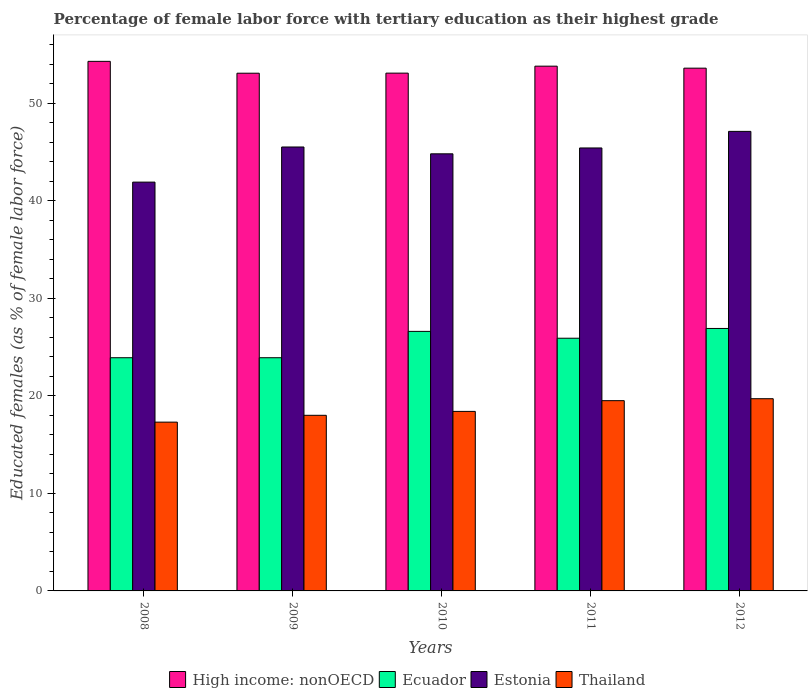How many groups of bars are there?
Your answer should be compact. 5. Are the number of bars per tick equal to the number of legend labels?
Ensure brevity in your answer.  Yes. How many bars are there on the 1st tick from the left?
Provide a succinct answer. 4. How many bars are there on the 3rd tick from the right?
Offer a very short reply. 4. What is the percentage of female labor force with tertiary education in Ecuador in 2009?
Ensure brevity in your answer.  23.9. Across all years, what is the maximum percentage of female labor force with tertiary education in Estonia?
Your response must be concise. 47.1. Across all years, what is the minimum percentage of female labor force with tertiary education in Ecuador?
Keep it short and to the point. 23.9. What is the total percentage of female labor force with tertiary education in Estonia in the graph?
Offer a terse response. 224.7. What is the difference between the percentage of female labor force with tertiary education in Thailand in 2011 and that in 2012?
Ensure brevity in your answer.  -0.2. What is the difference between the percentage of female labor force with tertiary education in Estonia in 2010 and the percentage of female labor force with tertiary education in Thailand in 2009?
Offer a very short reply. 26.8. What is the average percentage of female labor force with tertiary education in Ecuador per year?
Offer a very short reply. 25.44. In the year 2011, what is the difference between the percentage of female labor force with tertiary education in Thailand and percentage of female labor force with tertiary education in Estonia?
Your response must be concise. -25.9. In how many years, is the percentage of female labor force with tertiary education in Ecuador greater than 46 %?
Your response must be concise. 0. What is the ratio of the percentage of female labor force with tertiary education in Estonia in 2008 to that in 2012?
Give a very brief answer. 0.89. What is the difference between the highest and the second highest percentage of female labor force with tertiary education in Estonia?
Ensure brevity in your answer.  1.6. What is the difference between the highest and the lowest percentage of female labor force with tertiary education in Estonia?
Make the answer very short. 5.2. In how many years, is the percentage of female labor force with tertiary education in High income: nonOECD greater than the average percentage of female labor force with tertiary education in High income: nonOECD taken over all years?
Make the answer very short. 3. Is the sum of the percentage of female labor force with tertiary education in Estonia in 2008 and 2011 greater than the maximum percentage of female labor force with tertiary education in Ecuador across all years?
Your answer should be compact. Yes. What does the 3rd bar from the left in 2010 represents?
Provide a short and direct response. Estonia. What does the 3rd bar from the right in 2011 represents?
Your response must be concise. Ecuador. Is it the case that in every year, the sum of the percentage of female labor force with tertiary education in Ecuador and percentage of female labor force with tertiary education in Thailand is greater than the percentage of female labor force with tertiary education in Estonia?
Offer a terse response. No. How many bars are there?
Your response must be concise. 20. How many years are there in the graph?
Provide a short and direct response. 5. Does the graph contain any zero values?
Provide a short and direct response. No. Does the graph contain grids?
Keep it short and to the point. No. Where does the legend appear in the graph?
Offer a very short reply. Bottom center. How many legend labels are there?
Provide a succinct answer. 4. How are the legend labels stacked?
Provide a succinct answer. Horizontal. What is the title of the graph?
Your answer should be compact. Percentage of female labor force with tertiary education as their highest grade. Does "Morocco" appear as one of the legend labels in the graph?
Your answer should be compact. No. What is the label or title of the Y-axis?
Keep it short and to the point. Educated females (as % of female labor force). What is the Educated females (as % of female labor force) of High income: nonOECD in 2008?
Your answer should be very brief. 54.28. What is the Educated females (as % of female labor force) of Ecuador in 2008?
Your answer should be very brief. 23.9. What is the Educated females (as % of female labor force) in Estonia in 2008?
Make the answer very short. 41.9. What is the Educated females (as % of female labor force) in Thailand in 2008?
Provide a short and direct response. 17.3. What is the Educated females (as % of female labor force) in High income: nonOECD in 2009?
Offer a terse response. 53.06. What is the Educated females (as % of female labor force) in Ecuador in 2009?
Your answer should be compact. 23.9. What is the Educated females (as % of female labor force) in Estonia in 2009?
Provide a short and direct response. 45.5. What is the Educated females (as % of female labor force) of High income: nonOECD in 2010?
Provide a succinct answer. 53.07. What is the Educated females (as % of female labor force) of Ecuador in 2010?
Keep it short and to the point. 26.6. What is the Educated females (as % of female labor force) of Estonia in 2010?
Make the answer very short. 44.8. What is the Educated females (as % of female labor force) of Thailand in 2010?
Ensure brevity in your answer.  18.4. What is the Educated females (as % of female labor force) in High income: nonOECD in 2011?
Offer a very short reply. 53.78. What is the Educated females (as % of female labor force) of Ecuador in 2011?
Your answer should be very brief. 25.9. What is the Educated females (as % of female labor force) in Estonia in 2011?
Offer a terse response. 45.4. What is the Educated females (as % of female labor force) of Thailand in 2011?
Ensure brevity in your answer.  19.5. What is the Educated females (as % of female labor force) of High income: nonOECD in 2012?
Offer a very short reply. 53.58. What is the Educated females (as % of female labor force) of Ecuador in 2012?
Provide a short and direct response. 26.9. What is the Educated females (as % of female labor force) in Estonia in 2012?
Offer a terse response. 47.1. What is the Educated females (as % of female labor force) of Thailand in 2012?
Give a very brief answer. 19.7. Across all years, what is the maximum Educated females (as % of female labor force) in High income: nonOECD?
Your response must be concise. 54.28. Across all years, what is the maximum Educated females (as % of female labor force) of Ecuador?
Make the answer very short. 26.9. Across all years, what is the maximum Educated females (as % of female labor force) in Estonia?
Offer a terse response. 47.1. Across all years, what is the maximum Educated females (as % of female labor force) of Thailand?
Give a very brief answer. 19.7. Across all years, what is the minimum Educated females (as % of female labor force) in High income: nonOECD?
Provide a succinct answer. 53.06. Across all years, what is the minimum Educated females (as % of female labor force) in Ecuador?
Make the answer very short. 23.9. Across all years, what is the minimum Educated females (as % of female labor force) in Estonia?
Offer a terse response. 41.9. Across all years, what is the minimum Educated females (as % of female labor force) of Thailand?
Give a very brief answer. 17.3. What is the total Educated females (as % of female labor force) in High income: nonOECD in the graph?
Offer a terse response. 267.77. What is the total Educated females (as % of female labor force) of Ecuador in the graph?
Keep it short and to the point. 127.2. What is the total Educated females (as % of female labor force) of Estonia in the graph?
Your response must be concise. 224.7. What is the total Educated females (as % of female labor force) of Thailand in the graph?
Offer a terse response. 92.9. What is the difference between the Educated females (as % of female labor force) in High income: nonOECD in 2008 and that in 2009?
Your response must be concise. 1.22. What is the difference between the Educated females (as % of female labor force) in Ecuador in 2008 and that in 2009?
Ensure brevity in your answer.  0. What is the difference between the Educated females (as % of female labor force) in High income: nonOECD in 2008 and that in 2010?
Make the answer very short. 1.21. What is the difference between the Educated females (as % of female labor force) in Ecuador in 2008 and that in 2010?
Your answer should be very brief. -2.7. What is the difference between the Educated females (as % of female labor force) in Estonia in 2008 and that in 2010?
Your response must be concise. -2.9. What is the difference between the Educated females (as % of female labor force) in High income: nonOECD in 2008 and that in 2011?
Ensure brevity in your answer.  0.49. What is the difference between the Educated females (as % of female labor force) in Thailand in 2008 and that in 2011?
Provide a succinct answer. -2.2. What is the difference between the Educated females (as % of female labor force) of High income: nonOECD in 2008 and that in 2012?
Ensure brevity in your answer.  0.7. What is the difference between the Educated females (as % of female labor force) in Ecuador in 2008 and that in 2012?
Make the answer very short. -3. What is the difference between the Educated females (as % of female labor force) in Estonia in 2008 and that in 2012?
Make the answer very short. -5.2. What is the difference between the Educated females (as % of female labor force) of Thailand in 2008 and that in 2012?
Make the answer very short. -2.4. What is the difference between the Educated females (as % of female labor force) in High income: nonOECD in 2009 and that in 2010?
Offer a very short reply. -0.01. What is the difference between the Educated females (as % of female labor force) in Ecuador in 2009 and that in 2010?
Your answer should be very brief. -2.7. What is the difference between the Educated females (as % of female labor force) of Estonia in 2009 and that in 2010?
Ensure brevity in your answer.  0.7. What is the difference between the Educated females (as % of female labor force) in High income: nonOECD in 2009 and that in 2011?
Your answer should be very brief. -0.72. What is the difference between the Educated females (as % of female labor force) in Thailand in 2009 and that in 2011?
Provide a succinct answer. -1.5. What is the difference between the Educated females (as % of female labor force) in High income: nonOECD in 2009 and that in 2012?
Give a very brief answer. -0.52. What is the difference between the Educated females (as % of female labor force) in Estonia in 2009 and that in 2012?
Make the answer very short. -1.6. What is the difference between the Educated females (as % of female labor force) of High income: nonOECD in 2010 and that in 2011?
Provide a succinct answer. -0.71. What is the difference between the Educated females (as % of female labor force) of Ecuador in 2010 and that in 2011?
Provide a short and direct response. 0.7. What is the difference between the Educated females (as % of female labor force) of High income: nonOECD in 2010 and that in 2012?
Your answer should be very brief. -0.51. What is the difference between the Educated females (as % of female labor force) of Ecuador in 2010 and that in 2012?
Keep it short and to the point. -0.3. What is the difference between the Educated females (as % of female labor force) in High income: nonOECD in 2011 and that in 2012?
Keep it short and to the point. 0.2. What is the difference between the Educated females (as % of female labor force) of Ecuador in 2011 and that in 2012?
Provide a succinct answer. -1. What is the difference between the Educated females (as % of female labor force) of High income: nonOECD in 2008 and the Educated females (as % of female labor force) of Ecuador in 2009?
Give a very brief answer. 30.38. What is the difference between the Educated females (as % of female labor force) of High income: nonOECD in 2008 and the Educated females (as % of female labor force) of Estonia in 2009?
Your response must be concise. 8.78. What is the difference between the Educated females (as % of female labor force) in High income: nonOECD in 2008 and the Educated females (as % of female labor force) in Thailand in 2009?
Offer a terse response. 36.28. What is the difference between the Educated females (as % of female labor force) in Ecuador in 2008 and the Educated females (as % of female labor force) in Estonia in 2009?
Provide a succinct answer. -21.6. What is the difference between the Educated females (as % of female labor force) of Estonia in 2008 and the Educated females (as % of female labor force) of Thailand in 2009?
Provide a succinct answer. 23.9. What is the difference between the Educated females (as % of female labor force) of High income: nonOECD in 2008 and the Educated females (as % of female labor force) of Ecuador in 2010?
Keep it short and to the point. 27.68. What is the difference between the Educated females (as % of female labor force) of High income: nonOECD in 2008 and the Educated females (as % of female labor force) of Estonia in 2010?
Provide a short and direct response. 9.48. What is the difference between the Educated females (as % of female labor force) of High income: nonOECD in 2008 and the Educated females (as % of female labor force) of Thailand in 2010?
Offer a terse response. 35.88. What is the difference between the Educated females (as % of female labor force) in Ecuador in 2008 and the Educated females (as % of female labor force) in Estonia in 2010?
Make the answer very short. -20.9. What is the difference between the Educated females (as % of female labor force) in High income: nonOECD in 2008 and the Educated females (as % of female labor force) in Ecuador in 2011?
Offer a terse response. 28.38. What is the difference between the Educated females (as % of female labor force) of High income: nonOECD in 2008 and the Educated females (as % of female labor force) of Estonia in 2011?
Make the answer very short. 8.88. What is the difference between the Educated females (as % of female labor force) in High income: nonOECD in 2008 and the Educated females (as % of female labor force) in Thailand in 2011?
Give a very brief answer. 34.78. What is the difference between the Educated females (as % of female labor force) in Ecuador in 2008 and the Educated females (as % of female labor force) in Estonia in 2011?
Ensure brevity in your answer.  -21.5. What is the difference between the Educated females (as % of female labor force) of Ecuador in 2008 and the Educated females (as % of female labor force) of Thailand in 2011?
Offer a terse response. 4.4. What is the difference between the Educated females (as % of female labor force) in Estonia in 2008 and the Educated females (as % of female labor force) in Thailand in 2011?
Provide a short and direct response. 22.4. What is the difference between the Educated females (as % of female labor force) of High income: nonOECD in 2008 and the Educated females (as % of female labor force) of Ecuador in 2012?
Provide a short and direct response. 27.38. What is the difference between the Educated females (as % of female labor force) of High income: nonOECD in 2008 and the Educated females (as % of female labor force) of Estonia in 2012?
Ensure brevity in your answer.  7.18. What is the difference between the Educated females (as % of female labor force) in High income: nonOECD in 2008 and the Educated females (as % of female labor force) in Thailand in 2012?
Provide a short and direct response. 34.58. What is the difference between the Educated females (as % of female labor force) of Ecuador in 2008 and the Educated females (as % of female labor force) of Estonia in 2012?
Your answer should be compact. -23.2. What is the difference between the Educated females (as % of female labor force) of Ecuador in 2008 and the Educated females (as % of female labor force) of Thailand in 2012?
Make the answer very short. 4.2. What is the difference between the Educated females (as % of female labor force) of High income: nonOECD in 2009 and the Educated females (as % of female labor force) of Ecuador in 2010?
Give a very brief answer. 26.46. What is the difference between the Educated females (as % of female labor force) in High income: nonOECD in 2009 and the Educated females (as % of female labor force) in Estonia in 2010?
Offer a terse response. 8.26. What is the difference between the Educated females (as % of female labor force) of High income: nonOECD in 2009 and the Educated females (as % of female labor force) of Thailand in 2010?
Your response must be concise. 34.66. What is the difference between the Educated females (as % of female labor force) in Ecuador in 2009 and the Educated females (as % of female labor force) in Estonia in 2010?
Make the answer very short. -20.9. What is the difference between the Educated females (as % of female labor force) of Ecuador in 2009 and the Educated females (as % of female labor force) of Thailand in 2010?
Ensure brevity in your answer.  5.5. What is the difference between the Educated females (as % of female labor force) in Estonia in 2009 and the Educated females (as % of female labor force) in Thailand in 2010?
Make the answer very short. 27.1. What is the difference between the Educated females (as % of female labor force) in High income: nonOECD in 2009 and the Educated females (as % of female labor force) in Ecuador in 2011?
Offer a terse response. 27.16. What is the difference between the Educated females (as % of female labor force) in High income: nonOECD in 2009 and the Educated females (as % of female labor force) in Estonia in 2011?
Your answer should be compact. 7.66. What is the difference between the Educated females (as % of female labor force) in High income: nonOECD in 2009 and the Educated females (as % of female labor force) in Thailand in 2011?
Keep it short and to the point. 33.56. What is the difference between the Educated females (as % of female labor force) of Ecuador in 2009 and the Educated females (as % of female labor force) of Estonia in 2011?
Provide a succinct answer. -21.5. What is the difference between the Educated females (as % of female labor force) of Ecuador in 2009 and the Educated females (as % of female labor force) of Thailand in 2011?
Your answer should be very brief. 4.4. What is the difference between the Educated females (as % of female labor force) in Estonia in 2009 and the Educated females (as % of female labor force) in Thailand in 2011?
Give a very brief answer. 26. What is the difference between the Educated females (as % of female labor force) in High income: nonOECD in 2009 and the Educated females (as % of female labor force) in Ecuador in 2012?
Your response must be concise. 26.16. What is the difference between the Educated females (as % of female labor force) of High income: nonOECD in 2009 and the Educated females (as % of female labor force) of Estonia in 2012?
Give a very brief answer. 5.96. What is the difference between the Educated females (as % of female labor force) of High income: nonOECD in 2009 and the Educated females (as % of female labor force) of Thailand in 2012?
Provide a short and direct response. 33.36. What is the difference between the Educated females (as % of female labor force) of Ecuador in 2009 and the Educated females (as % of female labor force) of Estonia in 2012?
Ensure brevity in your answer.  -23.2. What is the difference between the Educated females (as % of female labor force) in Estonia in 2009 and the Educated females (as % of female labor force) in Thailand in 2012?
Offer a terse response. 25.8. What is the difference between the Educated females (as % of female labor force) in High income: nonOECD in 2010 and the Educated females (as % of female labor force) in Ecuador in 2011?
Make the answer very short. 27.17. What is the difference between the Educated females (as % of female labor force) in High income: nonOECD in 2010 and the Educated females (as % of female labor force) in Estonia in 2011?
Offer a terse response. 7.67. What is the difference between the Educated females (as % of female labor force) in High income: nonOECD in 2010 and the Educated females (as % of female labor force) in Thailand in 2011?
Offer a terse response. 33.57. What is the difference between the Educated females (as % of female labor force) of Ecuador in 2010 and the Educated females (as % of female labor force) of Estonia in 2011?
Offer a terse response. -18.8. What is the difference between the Educated females (as % of female labor force) of Estonia in 2010 and the Educated females (as % of female labor force) of Thailand in 2011?
Offer a terse response. 25.3. What is the difference between the Educated females (as % of female labor force) of High income: nonOECD in 2010 and the Educated females (as % of female labor force) of Ecuador in 2012?
Make the answer very short. 26.17. What is the difference between the Educated females (as % of female labor force) in High income: nonOECD in 2010 and the Educated females (as % of female labor force) in Estonia in 2012?
Provide a short and direct response. 5.97. What is the difference between the Educated females (as % of female labor force) in High income: nonOECD in 2010 and the Educated females (as % of female labor force) in Thailand in 2012?
Keep it short and to the point. 33.37. What is the difference between the Educated females (as % of female labor force) in Ecuador in 2010 and the Educated females (as % of female labor force) in Estonia in 2012?
Your response must be concise. -20.5. What is the difference between the Educated females (as % of female labor force) of Estonia in 2010 and the Educated females (as % of female labor force) of Thailand in 2012?
Give a very brief answer. 25.1. What is the difference between the Educated females (as % of female labor force) in High income: nonOECD in 2011 and the Educated females (as % of female labor force) in Ecuador in 2012?
Your answer should be compact. 26.88. What is the difference between the Educated females (as % of female labor force) of High income: nonOECD in 2011 and the Educated females (as % of female labor force) of Estonia in 2012?
Offer a very short reply. 6.68. What is the difference between the Educated females (as % of female labor force) in High income: nonOECD in 2011 and the Educated females (as % of female labor force) in Thailand in 2012?
Your response must be concise. 34.08. What is the difference between the Educated females (as % of female labor force) of Ecuador in 2011 and the Educated females (as % of female labor force) of Estonia in 2012?
Make the answer very short. -21.2. What is the difference between the Educated females (as % of female labor force) in Ecuador in 2011 and the Educated females (as % of female labor force) in Thailand in 2012?
Provide a succinct answer. 6.2. What is the difference between the Educated females (as % of female labor force) in Estonia in 2011 and the Educated females (as % of female labor force) in Thailand in 2012?
Your answer should be very brief. 25.7. What is the average Educated females (as % of female labor force) of High income: nonOECD per year?
Ensure brevity in your answer.  53.55. What is the average Educated females (as % of female labor force) of Ecuador per year?
Keep it short and to the point. 25.44. What is the average Educated females (as % of female labor force) of Estonia per year?
Offer a very short reply. 44.94. What is the average Educated females (as % of female labor force) of Thailand per year?
Your answer should be compact. 18.58. In the year 2008, what is the difference between the Educated females (as % of female labor force) in High income: nonOECD and Educated females (as % of female labor force) in Ecuador?
Keep it short and to the point. 30.38. In the year 2008, what is the difference between the Educated females (as % of female labor force) of High income: nonOECD and Educated females (as % of female labor force) of Estonia?
Keep it short and to the point. 12.38. In the year 2008, what is the difference between the Educated females (as % of female labor force) of High income: nonOECD and Educated females (as % of female labor force) of Thailand?
Ensure brevity in your answer.  36.98. In the year 2008, what is the difference between the Educated females (as % of female labor force) in Ecuador and Educated females (as % of female labor force) in Estonia?
Your answer should be compact. -18. In the year 2008, what is the difference between the Educated females (as % of female labor force) of Estonia and Educated females (as % of female labor force) of Thailand?
Give a very brief answer. 24.6. In the year 2009, what is the difference between the Educated females (as % of female labor force) in High income: nonOECD and Educated females (as % of female labor force) in Ecuador?
Keep it short and to the point. 29.16. In the year 2009, what is the difference between the Educated females (as % of female labor force) in High income: nonOECD and Educated females (as % of female labor force) in Estonia?
Keep it short and to the point. 7.56. In the year 2009, what is the difference between the Educated females (as % of female labor force) in High income: nonOECD and Educated females (as % of female labor force) in Thailand?
Your response must be concise. 35.06. In the year 2009, what is the difference between the Educated females (as % of female labor force) in Ecuador and Educated females (as % of female labor force) in Estonia?
Your answer should be compact. -21.6. In the year 2009, what is the difference between the Educated females (as % of female labor force) of Estonia and Educated females (as % of female labor force) of Thailand?
Your response must be concise. 27.5. In the year 2010, what is the difference between the Educated females (as % of female labor force) in High income: nonOECD and Educated females (as % of female labor force) in Ecuador?
Your response must be concise. 26.47. In the year 2010, what is the difference between the Educated females (as % of female labor force) in High income: nonOECD and Educated females (as % of female labor force) in Estonia?
Offer a very short reply. 8.27. In the year 2010, what is the difference between the Educated females (as % of female labor force) of High income: nonOECD and Educated females (as % of female labor force) of Thailand?
Your answer should be compact. 34.67. In the year 2010, what is the difference between the Educated females (as % of female labor force) in Ecuador and Educated females (as % of female labor force) in Estonia?
Offer a very short reply. -18.2. In the year 2010, what is the difference between the Educated females (as % of female labor force) in Estonia and Educated females (as % of female labor force) in Thailand?
Ensure brevity in your answer.  26.4. In the year 2011, what is the difference between the Educated females (as % of female labor force) in High income: nonOECD and Educated females (as % of female labor force) in Ecuador?
Provide a succinct answer. 27.88. In the year 2011, what is the difference between the Educated females (as % of female labor force) in High income: nonOECD and Educated females (as % of female labor force) in Estonia?
Provide a succinct answer. 8.38. In the year 2011, what is the difference between the Educated females (as % of female labor force) in High income: nonOECD and Educated females (as % of female labor force) in Thailand?
Your answer should be compact. 34.28. In the year 2011, what is the difference between the Educated females (as % of female labor force) in Ecuador and Educated females (as % of female labor force) in Estonia?
Make the answer very short. -19.5. In the year 2011, what is the difference between the Educated females (as % of female labor force) of Ecuador and Educated females (as % of female labor force) of Thailand?
Offer a terse response. 6.4. In the year 2011, what is the difference between the Educated females (as % of female labor force) in Estonia and Educated females (as % of female labor force) in Thailand?
Give a very brief answer. 25.9. In the year 2012, what is the difference between the Educated females (as % of female labor force) of High income: nonOECD and Educated females (as % of female labor force) of Ecuador?
Your response must be concise. 26.68. In the year 2012, what is the difference between the Educated females (as % of female labor force) of High income: nonOECD and Educated females (as % of female labor force) of Estonia?
Make the answer very short. 6.48. In the year 2012, what is the difference between the Educated females (as % of female labor force) of High income: nonOECD and Educated females (as % of female labor force) of Thailand?
Your answer should be compact. 33.88. In the year 2012, what is the difference between the Educated females (as % of female labor force) of Ecuador and Educated females (as % of female labor force) of Estonia?
Ensure brevity in your answer.  -20.2. In the year 2012, what is the difference between the Educated females (as % of female labor force) of Estonia and Educated females (as % of female labor force) of Thailand?
Ensure brevity in your answer.  27.4. What is the ratio of the Educated females (as % of female labor force) in High income: nonOECD in 2008 to that in 2009?
Give a very brief answer. 1.02. What is the ratio of the Educated females (as % of female labor force) of Ecuador in 2008 to that in 2009?
Offer a very short reply. 1. What is the ratio of the Educated females (as % of female labor force) of Estonia in 2008 to that in 2009?
Your answer should be compact. 0.92. What is the ratio of the Educated females (as % of female labor force) in Thailand in 2008 to that in 2009?
Provide a succinct answer. 0.96. What is the ratio of the Educated females (as % of female labor force) in High income: nonOECD in 2008 to that in 2010?
Offer a very short reply. 1.02. What is the ratio of the Educated females (as % of female labor force) in Ecuador in 2008 to that in 2010?
Give a very brief answer. 0.9. What is the ratio of the Educated females (as % of female labor force) of Estonia in 2008 to that in 2010?
Your answer should be compact. 0.94. What is the ratio of the Educated females (as % of female labor force) in Thailand in 2008 to that in 2010?
Your answer should be compact. 0.94. What is the ratio of the Educated females (as % of female labor force) in High income: nonOECD in 2008 to that in 2011?
Your answer should be very brief. 1.01. What is the ratio of the Educated females (as % of female labor force) of Ecuador in 2008 to that in 2011?
Provide a succinct answer. 0.92. What is the ratio of the Educated females (as % of female labor force) of Estonia in 2008 to that in 2011?
Ensure brevity in your answer.  0.92. What is the ratio of the Educated females (as % of female labor force) in Thailand in 2008 to that in 2011?
Offer a terse response. 0.89. What is the ratio of the Educated females (as % of female labor force) of High income: nonOECD in 2008 to that in 2012?
Make the answer very short. 1.01. What is the ratio of the Educated females (as % of female labor force) in Ecuador in 2008 to that in 2012?
Provide a short and direct response. 0.89. What is the ratio of the Educated females (as % of female labor force) in Estonia in 2008 to that in 2012?
Your response must be concise. 0.89. What is the ratio of the Educated females (as % of female labor force) in Thailand in 2008 to that in 2012?
Ensure brevity in your answer.  0.88. What is the ratio of the Educated females (as % of female labor force) in High income: nonOECD in 2009 to that in 2010?
Keep it short and to the point. 1. What is the ratio of the Educated females (as % of female labor force) of Ecuador in 2009 to that in 2010?
Ensure brevity in your answer.  0.9. What is the ratio of the Educated females (as % of female labor force) of Estonia in 2009 to that in 2010?
Provide a short and direct response. 1.02. What is the ratio of the Educated females (as % of female labor force) of Thailand in 2009 to that in 2010?
Keep it short and to the point. 0.98. What is the ratio of the Educated females (as % of female labor force) in High income: nonOECD in 2009 to that in 2011?
Your answer should be very brief. 0.99. What is the ratio of the Educated females (as % of female labor force) in Ecuador in 2009 to that in 2011?
Give a very brief answer. 0.92. What is the ratio of the Educated females (as % of female labor force) in Estonia in 2009 to that in 2011?
Provide a succinct answer. 1. What is the ratio of the Educated females (as % of female labor force) of Thailand in 2009 to that in 2011?
Give a very brief answer. 0.92. What is the ratio of the Educated females (as % of female labor force) in Ecuador in 2009 to that in 2012?
Ensure brevity in your answer.  0.89. What is the ratio of the Educated females (as % of female labor force) of Estonia in 2009 to that in 2012?
Provide a succinct answer. 0.97. What is the ratio of the Educated females (as % of female labor force) of Thailand in 2009 to that in 2012?
Offer a very short reply. 0.91. What is the ratio of the Educated females (as % of female labor force) in High income: nonOECD in 2010 to that in 2011?
Keep it short and to the point. 0.99. What is the ratio of the Educated females (as % of female labor force) of Ecuador in 2010 to that in 2011?
Offer a very short reply. 1.03. What is the ratio of the Educated females (as % of female labor force) of Estonia in 2010 to that in 2011?
Make the answer very short. 0.99. What is the ratio of the Educated females (as % of female labor force) in Thailand in 2010 to that in 2011?
Provide a short and direct response. 0.94. What is the ratio of the Educated females (as % of female labor force) in Estonia in 2010 to that in 2012?
Your answer should be compact. 0.95. What is the ratio of the Educated females (as % of female labor force) in Thailand in 2010 to that in 2012?
Your answer should be very brief. 0.93. What is the ratio of the Educated females (as % of female labor force) of High income: nonOECD in 2011 to that in 2012?
Offer a terse response. 1. What is the ratio of the Educated females (as % of female labor force) in Ecuador in 2011 to that in 2012?
Your response must be concise. 0.96. What is the ratio of the Educated females (as % of female labor force) of Estonia in 2011 to that in 2012?
Give a very brief answer. 0.96. What is the difference between the highest and the second highest Educated females (as % of female labor force) of High income: nonOECD?
Your response must be concise. 0.49. What is the difference between the highest and the second highest Educated females (as % of female labor force) in Ecuador?
Keep it short and to the point. 0.3. What is the difference between the highest and the second highest Educated females (as % of female labor force) in Thailand?
Offer a very short reply. 0.2. What is the difference between the highest and the lowest Educated females (as % of female labor force) in High income: nonOECD?
Your answer should be very brief. 1.22. What is the difference between the highest and the lowest Educated females (as % of female labor force) of Ecuador?
Provide a short and direct response. 3. 